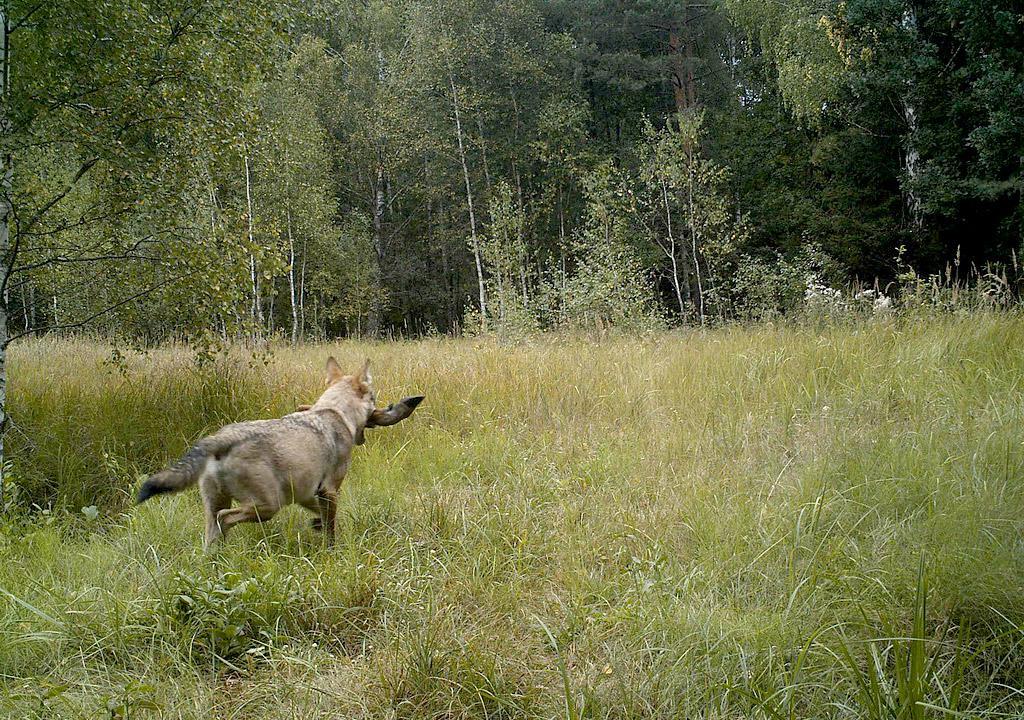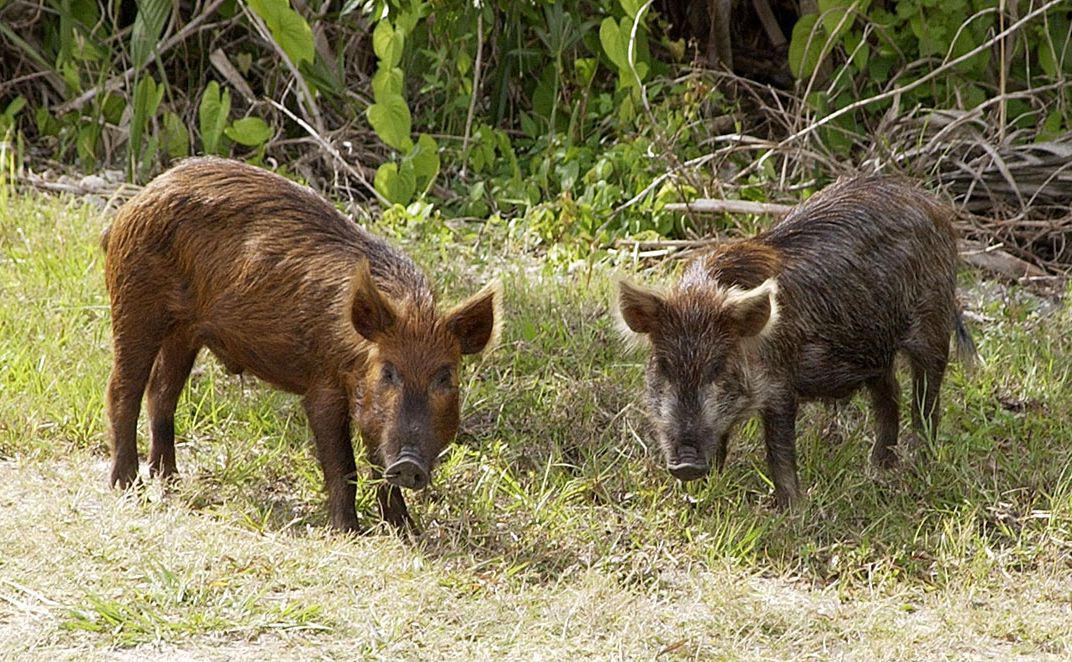The first image is the image on the left, the second image is the image on the right. For the images displayed, is the sentence "There is at least one image in which there is a person near the boar." factually correct? Answer yes or no. No. The first image is the image on the left, the second image is the image on the right. Examine the images to the left and right. Is the description "There is a human feeding one of the pigs." accurate? Answer yes or no. No. 